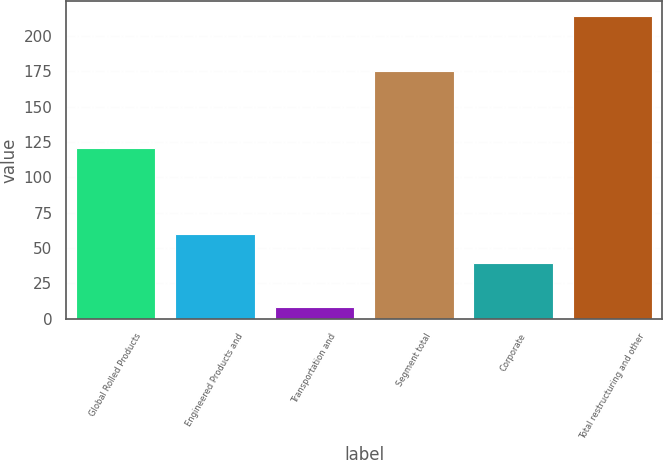<chart> <loc_0><loc_0><loc_500><loc_500><bar_chart><fcel>Global Rolled Products<fcel>Engineered Products and<fcel>Transportation and<fcel>Segment total<fcel>Corporate<fcel>Total restructuring and other<nl><fcel>121<fcel>59.6<fcel>8<fcel>175<fcel>39<fcel>214<nl></chart> 